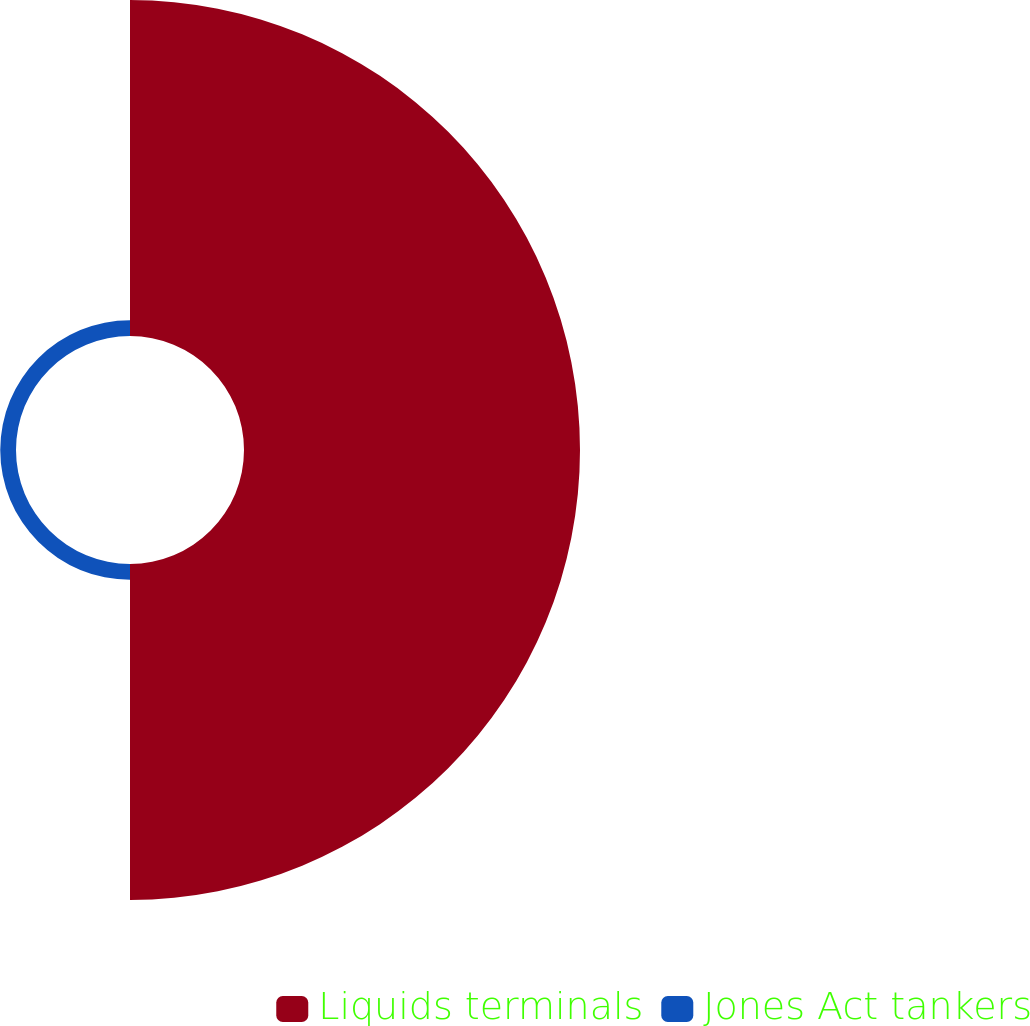<chart> <loc_0><loc_0><loc_500><loc_500><pie_chart><fcel>Liquids terminals<fcel>Jones Act tankers<nl><fcel>95.52%<fcel>4.48%<nl></chart> 